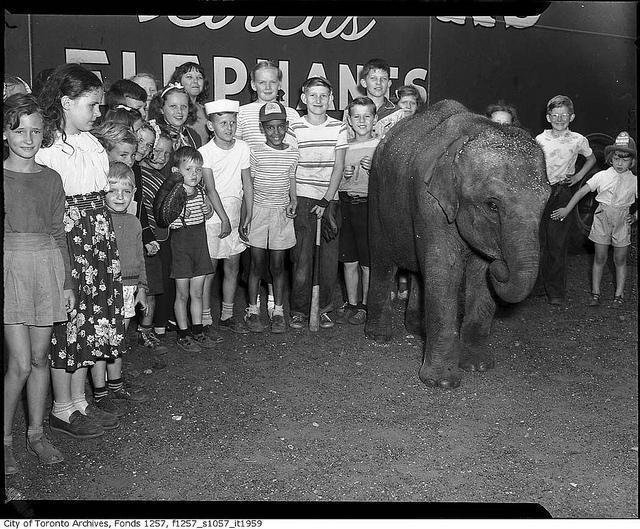What is the elephants trunk doing?
Indicate the correct response and explain using: 'Answer: answer
Rationale: rationale.'
Options: Curling, spraying, drawing, grabbing. Answer: curling.
Rationale: The elephant's trunk is folded under and twisted around, which is a curling motion. 